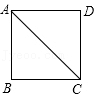First perform reasoning, then finally select the question from the choices in the following format: Answer: xxx.
Question: In the given diagram, if AB in square ABCD is equal to 1 unit, what is the length of AC? 
Choices:
A: 1
B: √{2}
C: √{3}
D: 2 In triangle ABC, AB=BC=1, therefore AC=√{AB2+BC2}=√{12+12}=√{2}; Hence the answer is B.
Answer:B 